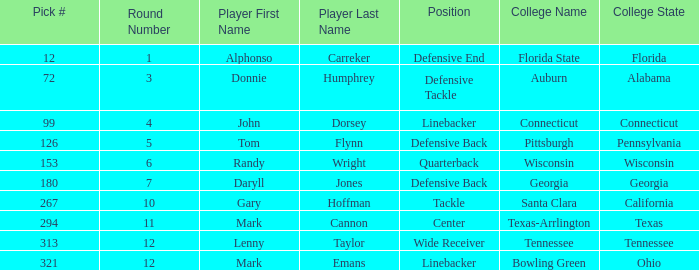What university is mark cannon a student at? Texas-Arrlington. 